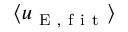<formula> <loc_0><loc_0><loc_500><loc_500>\langle u _ { E , f i t } \rangle</formula> 